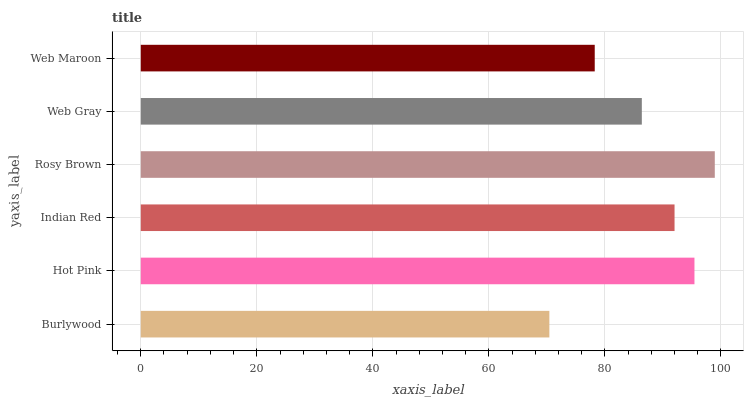Is Burlywood the minimum?
Answer yes or no. Yes. Is Rosy Brown the maximum?
Answer yes or no. Yes. Is Hot Pink the minimum?
Answer yes or no. No. Is Hot Pink the maximum?
Answer yes or no. No. Is Hot Pink greater than Burlywood?
Answer yes or no. Yes. Is Burlywood less than Hot Pink?
Answer yes or no. Yes. Is Burlywood greater than Hot Pink?
Answer yes or no. No. Is Hot Pink less than Burlywood?
Answer yes or no. No. Is Indian Red the high median?
Answer yes or no. Yes. Is Web Gray the low median?
Answer yes or no. Yes. Is Hot Pink the high median?
Answer yes or no. No. Is Web Maroon the low median?
Answer yes or no. No. 